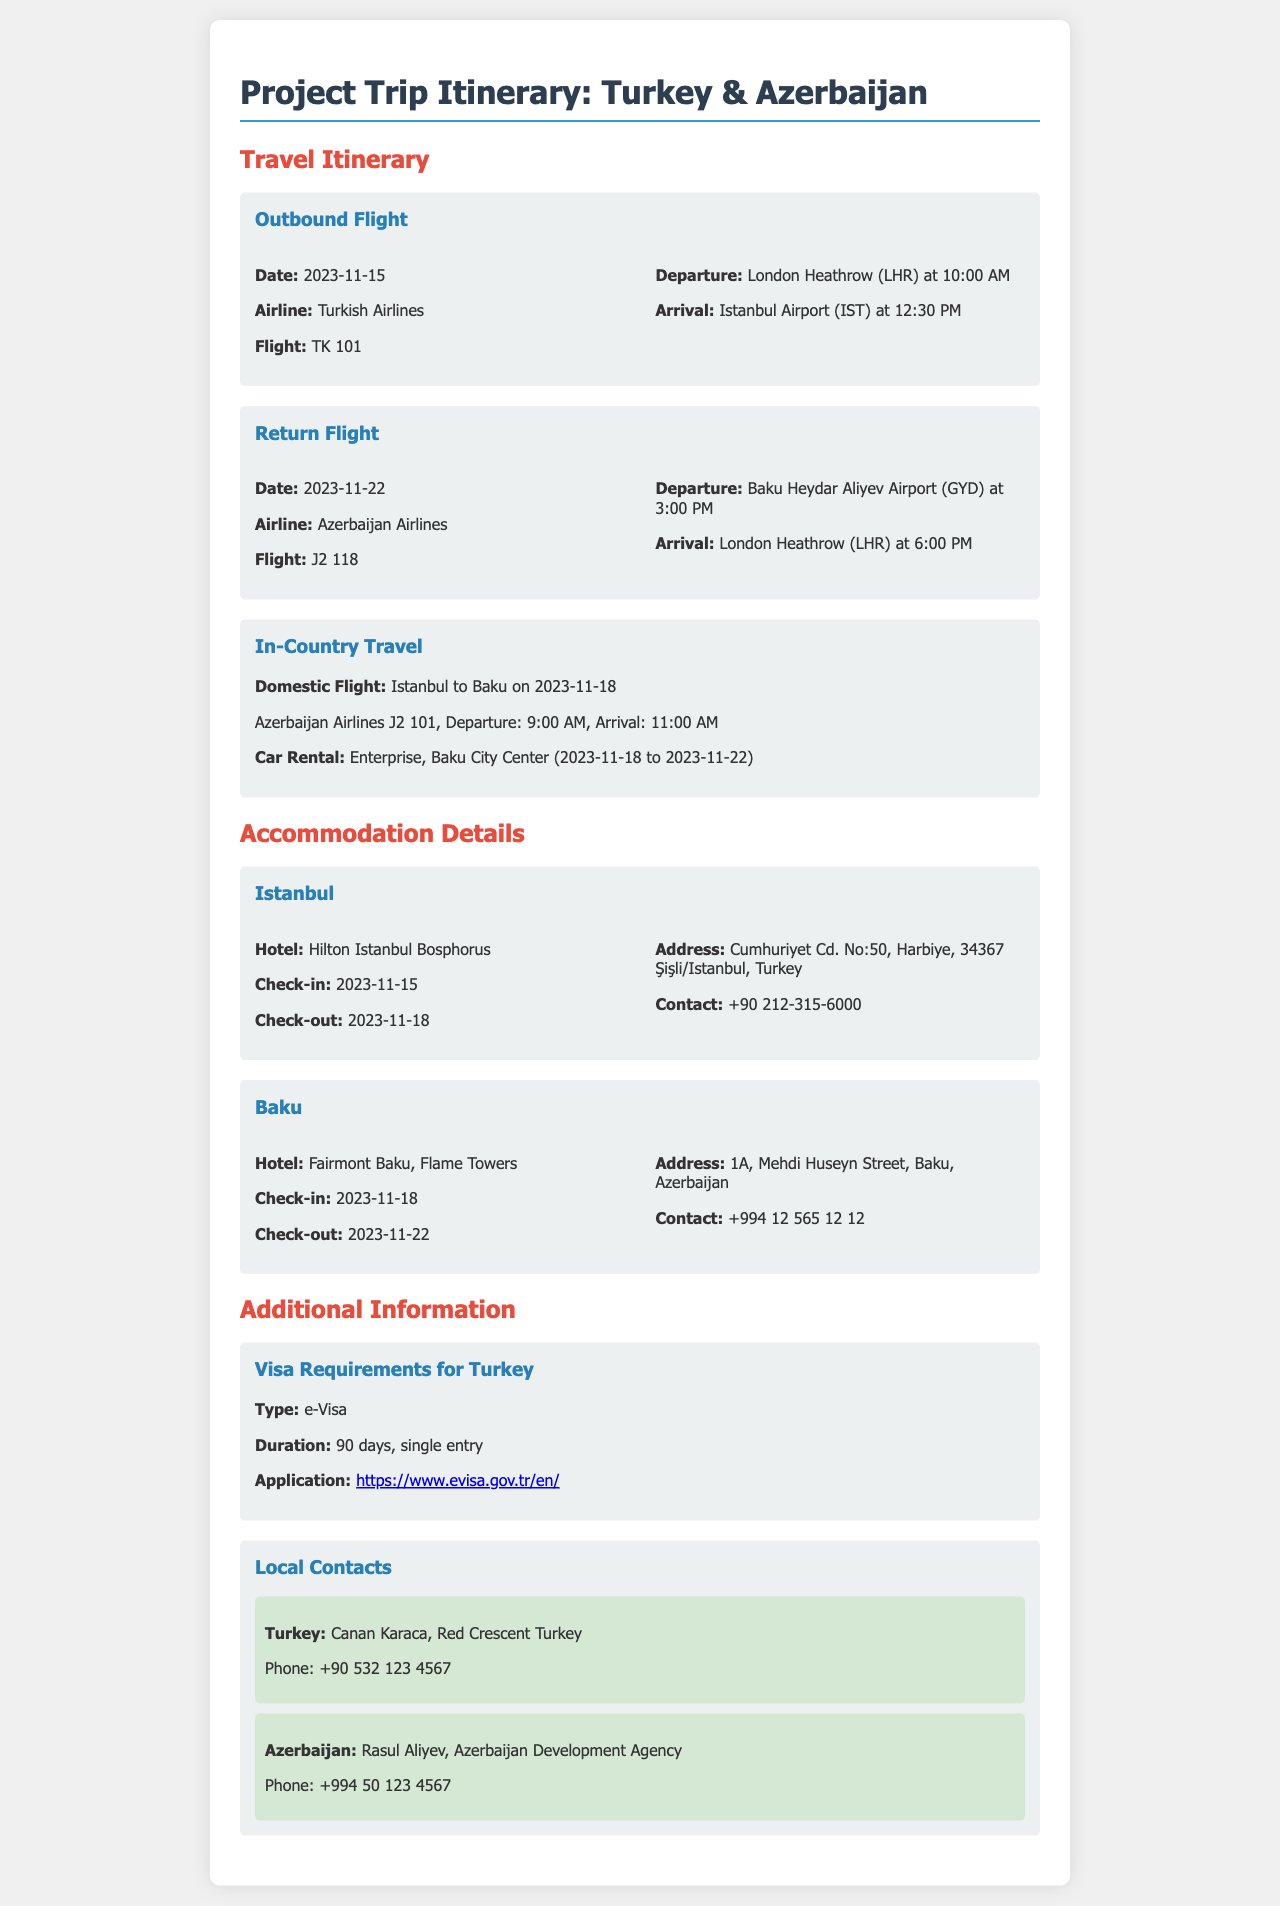what is the departure date for the outbound flight? The departure date for the outbound flight is specified in the document.
Answer: 2023-11-15 which airline operates the return flight? The return flight information includes the airline name.
Answer: Azerbaijan Airlines what is the check-out date for the hotel in Baku? The document specifies the check-out date for the Baku hotel.
Answer: 2023-11-22 who is the local contact in Turkey? The document lists the local contacts for each country.
Answer: Canan Karaca how long is the visa duration for Turkey? The visa requirements section provides the duration of the visa.
Answer: 90 days what time does the flight from Istanbul to Baku depart? The in-country travel section includes the departure time for this flight.
Answer: 9:00 AM what is the address of the Hilton Istanbul Bosphorus? The accommodation details specify the address for the Istanbul hotel.
Answer: Cumhuriyet Cd. No:50, Harbiye, 34367 Şişli/Istanbul, Turkey what type of visa is required for Turkey? The visa requirements section identifies the type of visa needed for entry into Turkey.
Answer: e-Visa 